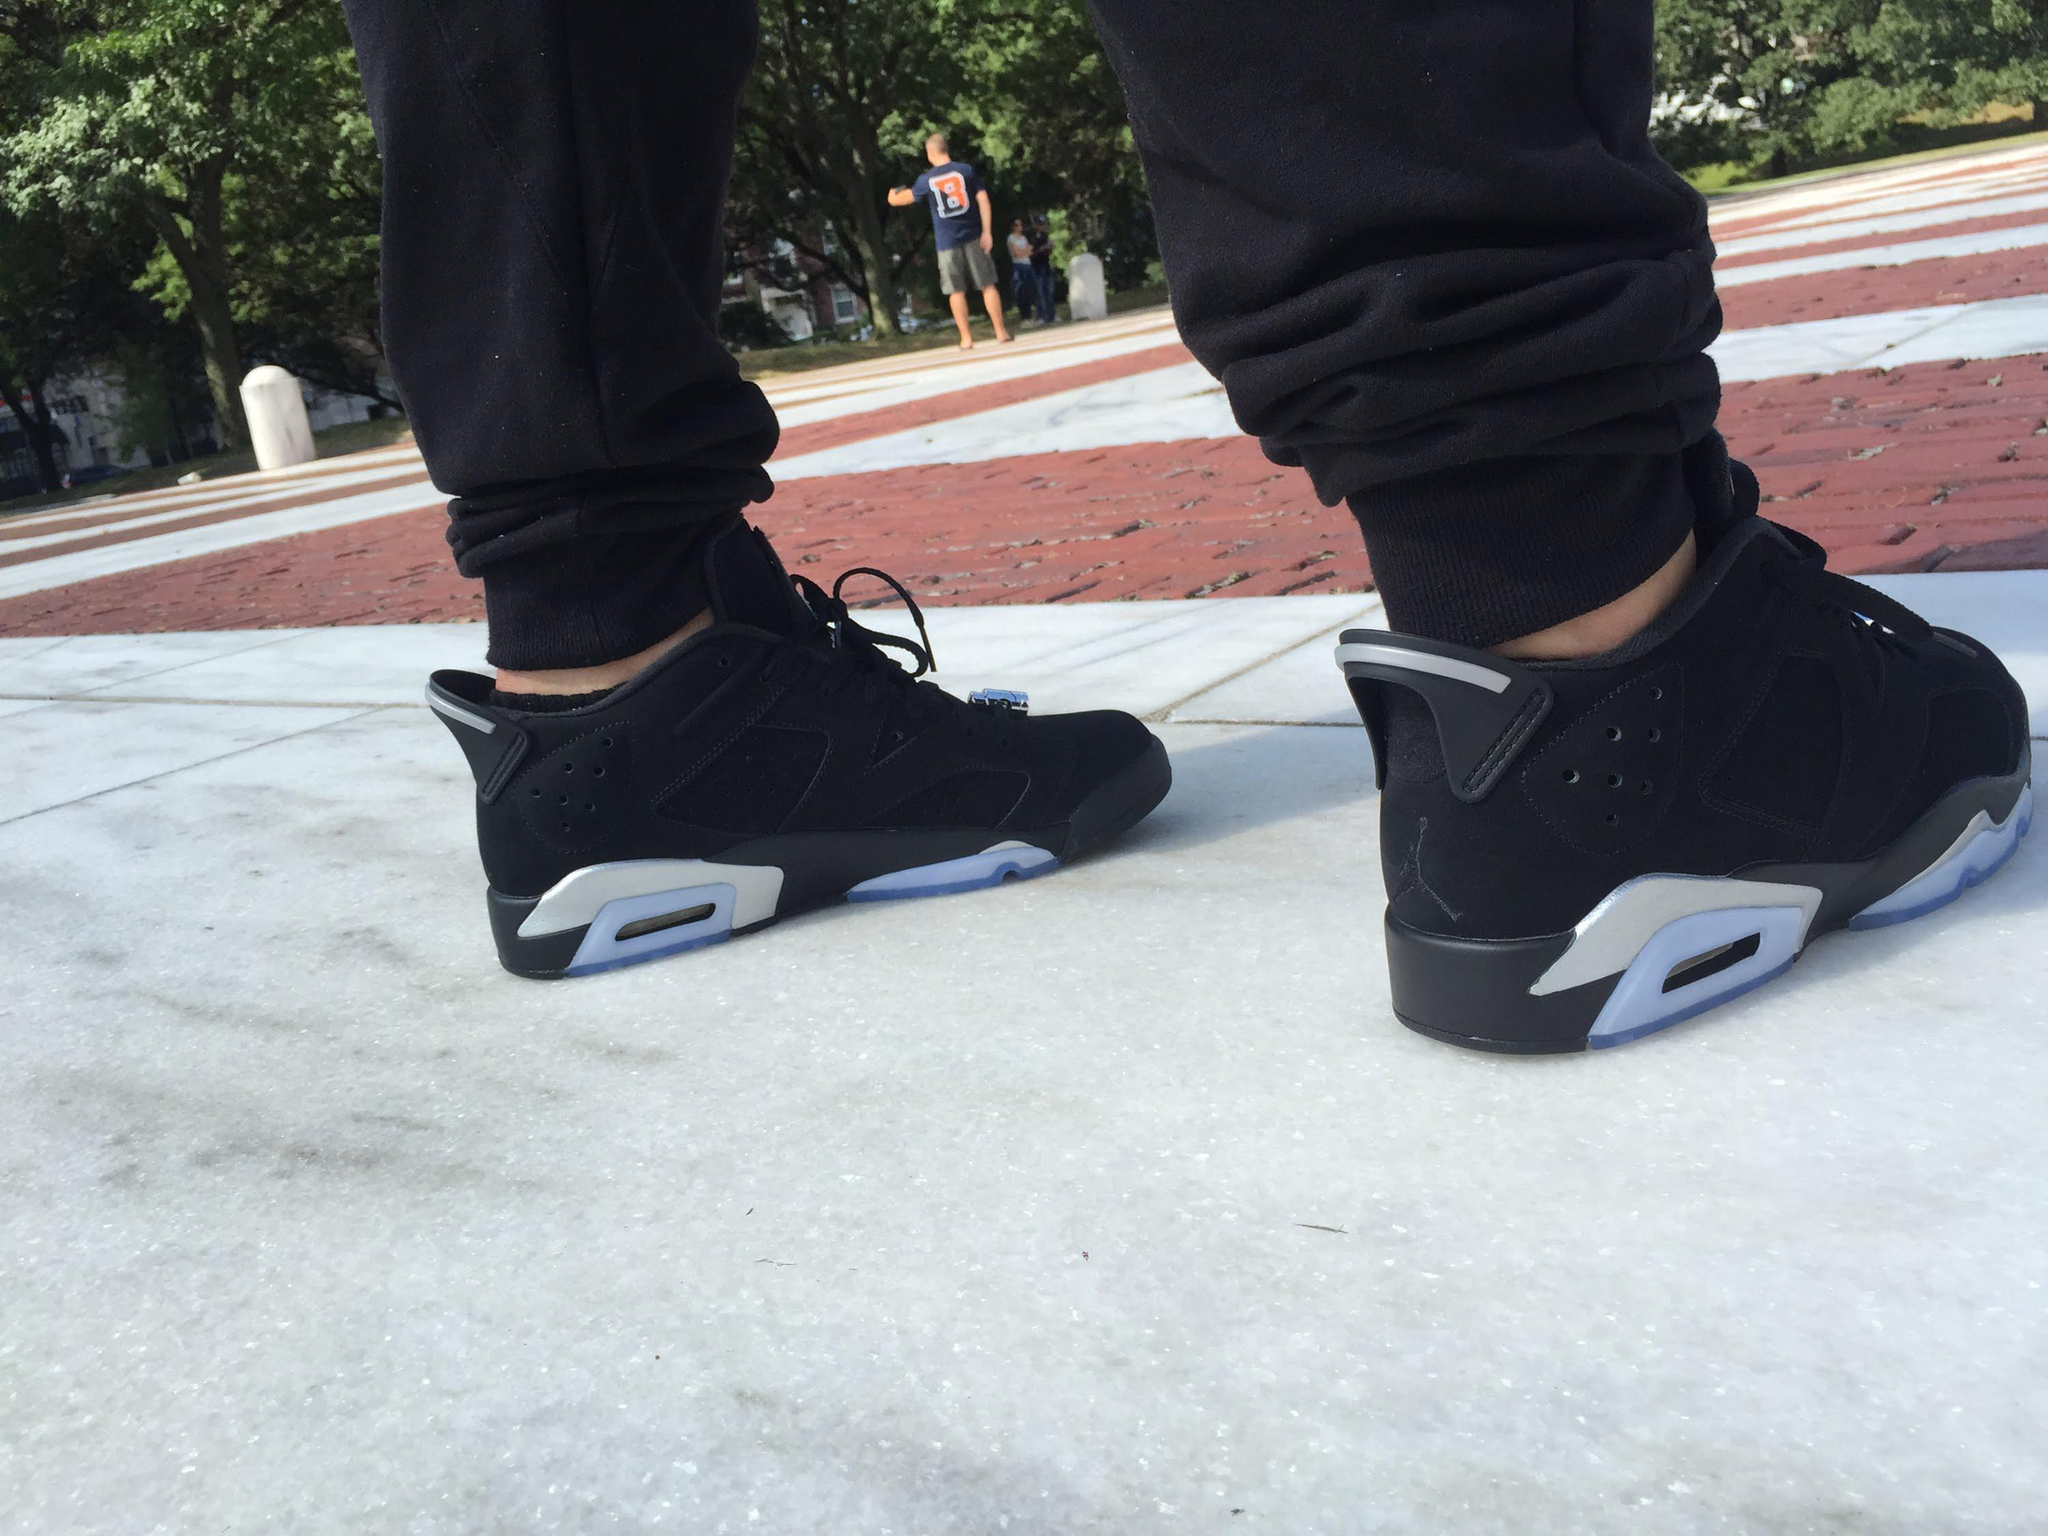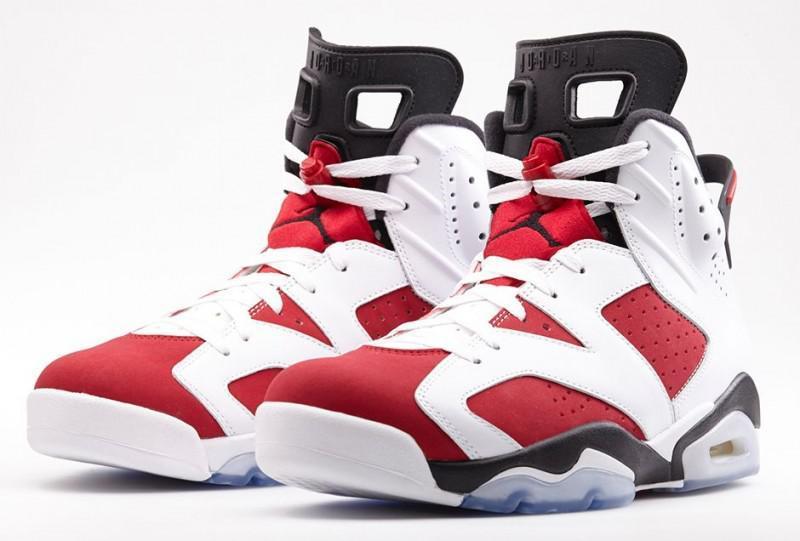The first image is the image on the left, the second image is the image on the right. Examine the images to the left and right. Is the description "At least one pair of sneakers is not shown worn by a person, and at least one pair of sneakers has red-and-white coloring." accurate? Answer yes or no. Yes. The first image is the image on the left, the second image is the image on the right. For the images displayed, is the sentence "At least one pair of shoes does not have any red color in it." factually correct? Answer yes or no. Yes. 